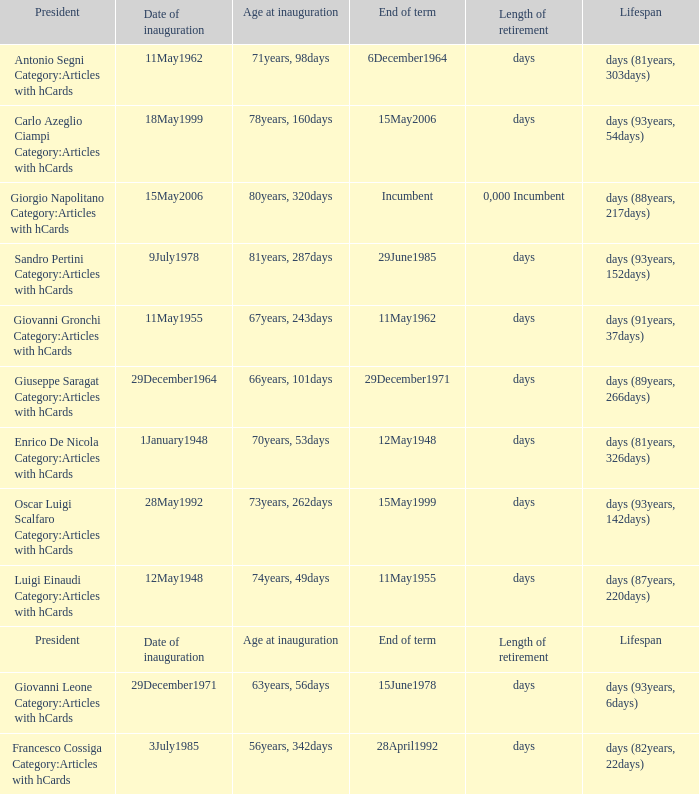What is the End of term of the President with an Age at inauguration of 78years, 160days? 15May2006. 